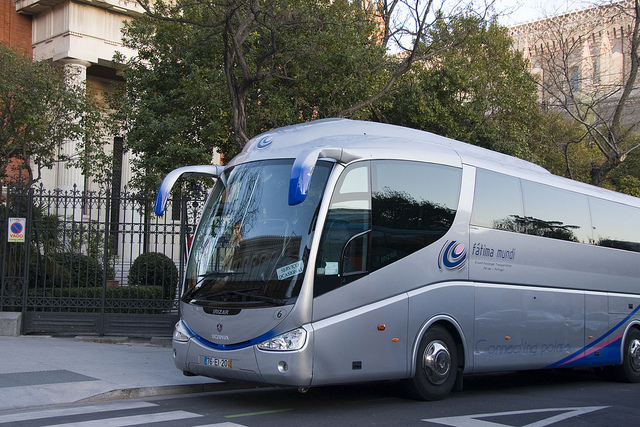Please extract the text content from this image. fatima Connecting 